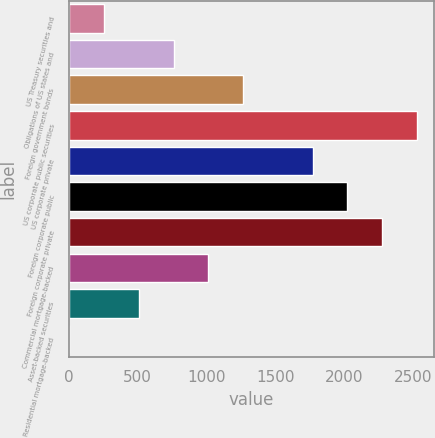Convert chart to OTSL. <chart><loc_0><loc_0><loc_500><loc_500><bar_chart><fcel>US Treasury securities and<fcel>Obligations of US states and<fcel>Foreign government bonds<fcel>US corporate public securities<fcel>US corporate private<fcel>Foreign corporate public<fcel>Foreign corporate private<fcel>Commercial mortgage-backed<fcel>Asset-backed securities<fcel>Residential mortgage-backed<nl><fcel>256.7<fcel>762.1<fcel>1267.5<fcel>2531<fcel>1772.9<fcel>2025.6<fcel>2278.3<fcel>1014.8<fcel>509.4<fcel>4<nl></chart> 